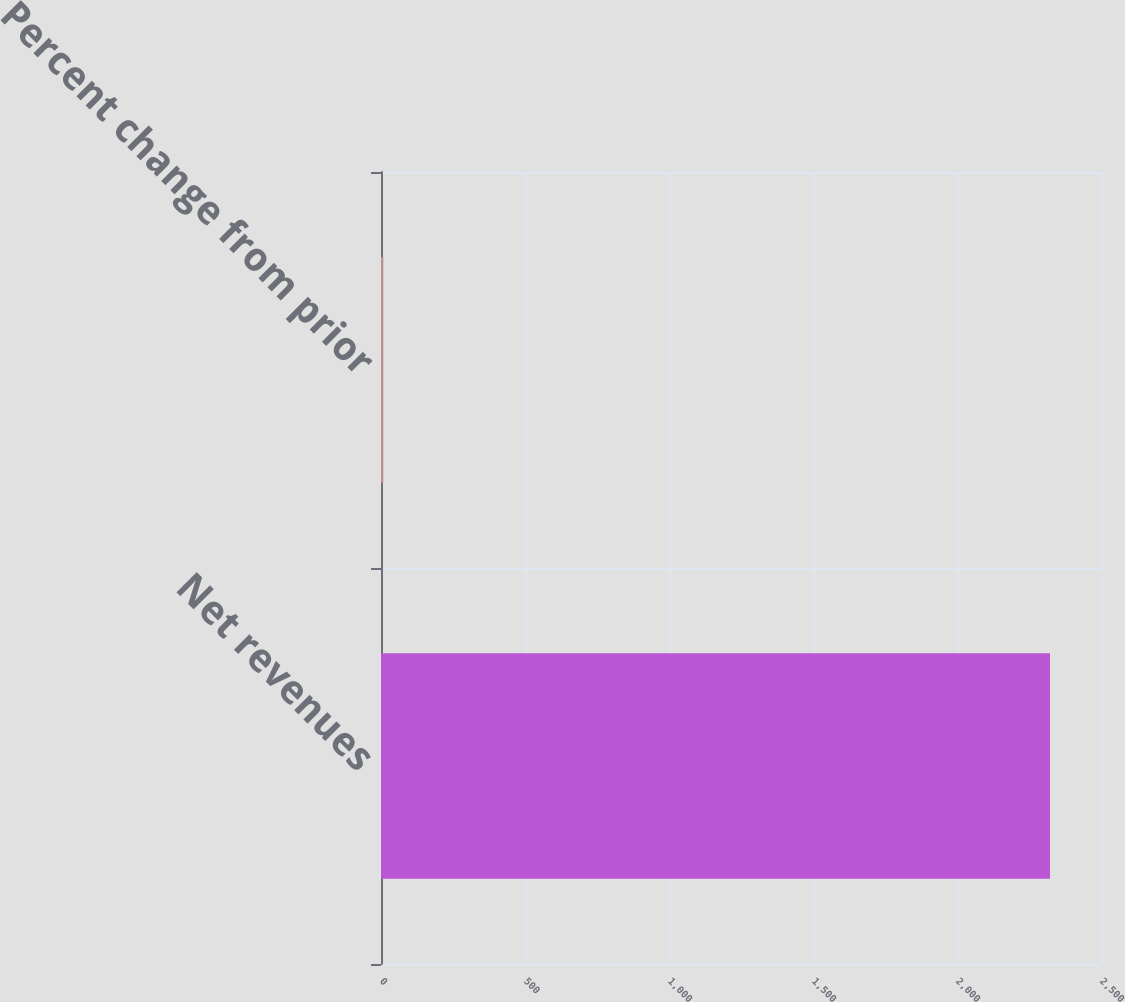Convert chart to OTSL. <chart><loc_0><loc_0><loc_500><loc_500><bar_chart><fcel>Net revenues<fcel>Percent change from prior<nl><fcel>2323<fcel>8<nl></chart> 